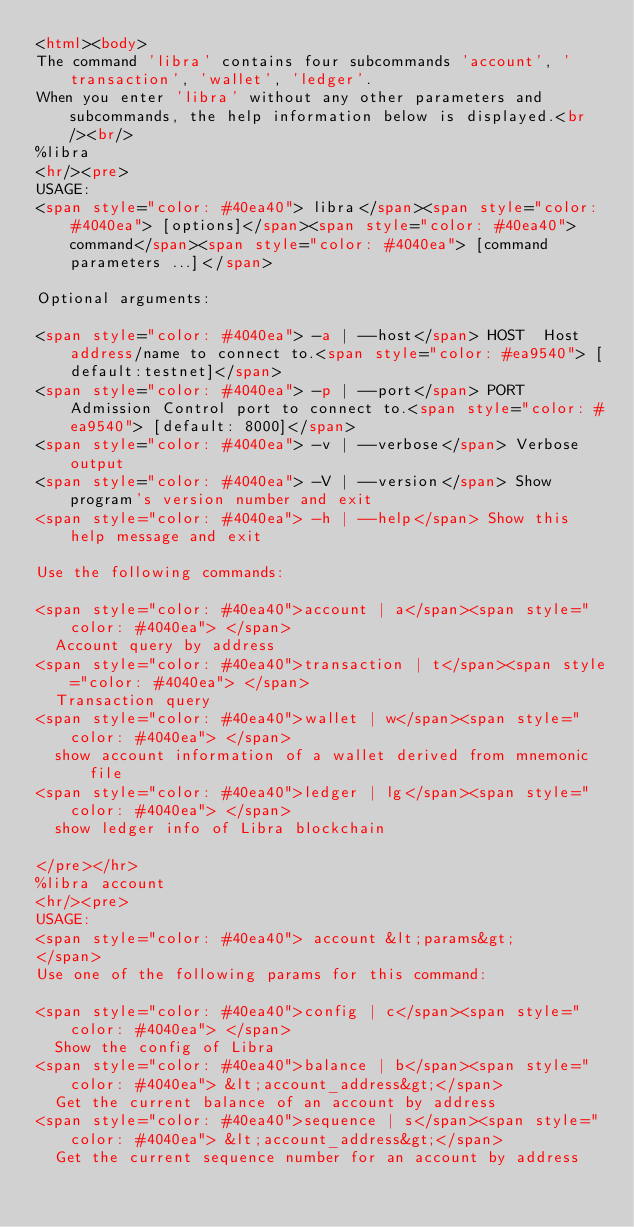Convert code to text. <code><loc_0><loc_0><loc_500><loc_500><_HTML_><html><body>
The command 'libra' contains four subcommands 'account', 'transaction', 'wallet', 'ledger'.
When you enter 'libra' without any other parameters and subcommands, the help information below is displayed.<br/><br/>
%libra
<hr/><pre>
USAGE:
<span style="color: #40ea40">	libra</span><span style="color: #4040ea"> [options]</span><span style="color: #40ea40"> command</span><span style="color: #4040ea"> [command parameters ...]</span>

Optional arguments:

<span style="color: #4040ea"> -a | --host</span> HOST  Host address/name to connect to.<span style="color: #ea9540"> [default:testnet]</span>
<span style="color: #4040ea"> -p | --port</span> PORT  Admission Control port to connect to.<span style="color: #ea9540"> [default: 8000]</span>
<span style="color: #4040ea"> -v | --verbose</span> Verbose output
<span style="color: #4040ea"> -V | --version</span> Show program's version number and exit
<span style="color: #4040ea"> -h | --help</span> Show this help message and exit

Use the following commands:

<span style="color: #40ea40">account | a</span><span style="color: #4040ea"> </span>
	Account query by address
<span style="color: #40ea40">transaction | t</span><span style="color: #4040ea"> </span>
	Transaction query
<span style="color: #40ea40">wallet | w</span><span style="color: #4040ea"> </span>
	show account information of a wallet derived from mnemonic file
<span style="color: #40ea40">ledger | lg</span><span style="color: #4040ea"> </span>
	show ledger info of Libra blockchain

</pre></hr>
%libra account
<hr/><pre>
USAGE:
<span style="color: #40ea40">	account &lt;params&gt;
</span>
Use one of the following params for this command:

<span style="color: #40ea40">config | c</span><span style="color: #4040ea"> </span>
	Show the config of Libra
<span style="color: #40ea40">balance | b</span><span style="color: #4040ea"> &lt;account_address&gt;</span>
	Get the current balance of an account by address
<span style="color: #40ea40">sequence | s</span><span style="color: #4040ea"> &lt;account_address&gt;</span>
	Get the current sequence number for an account by address</code> 